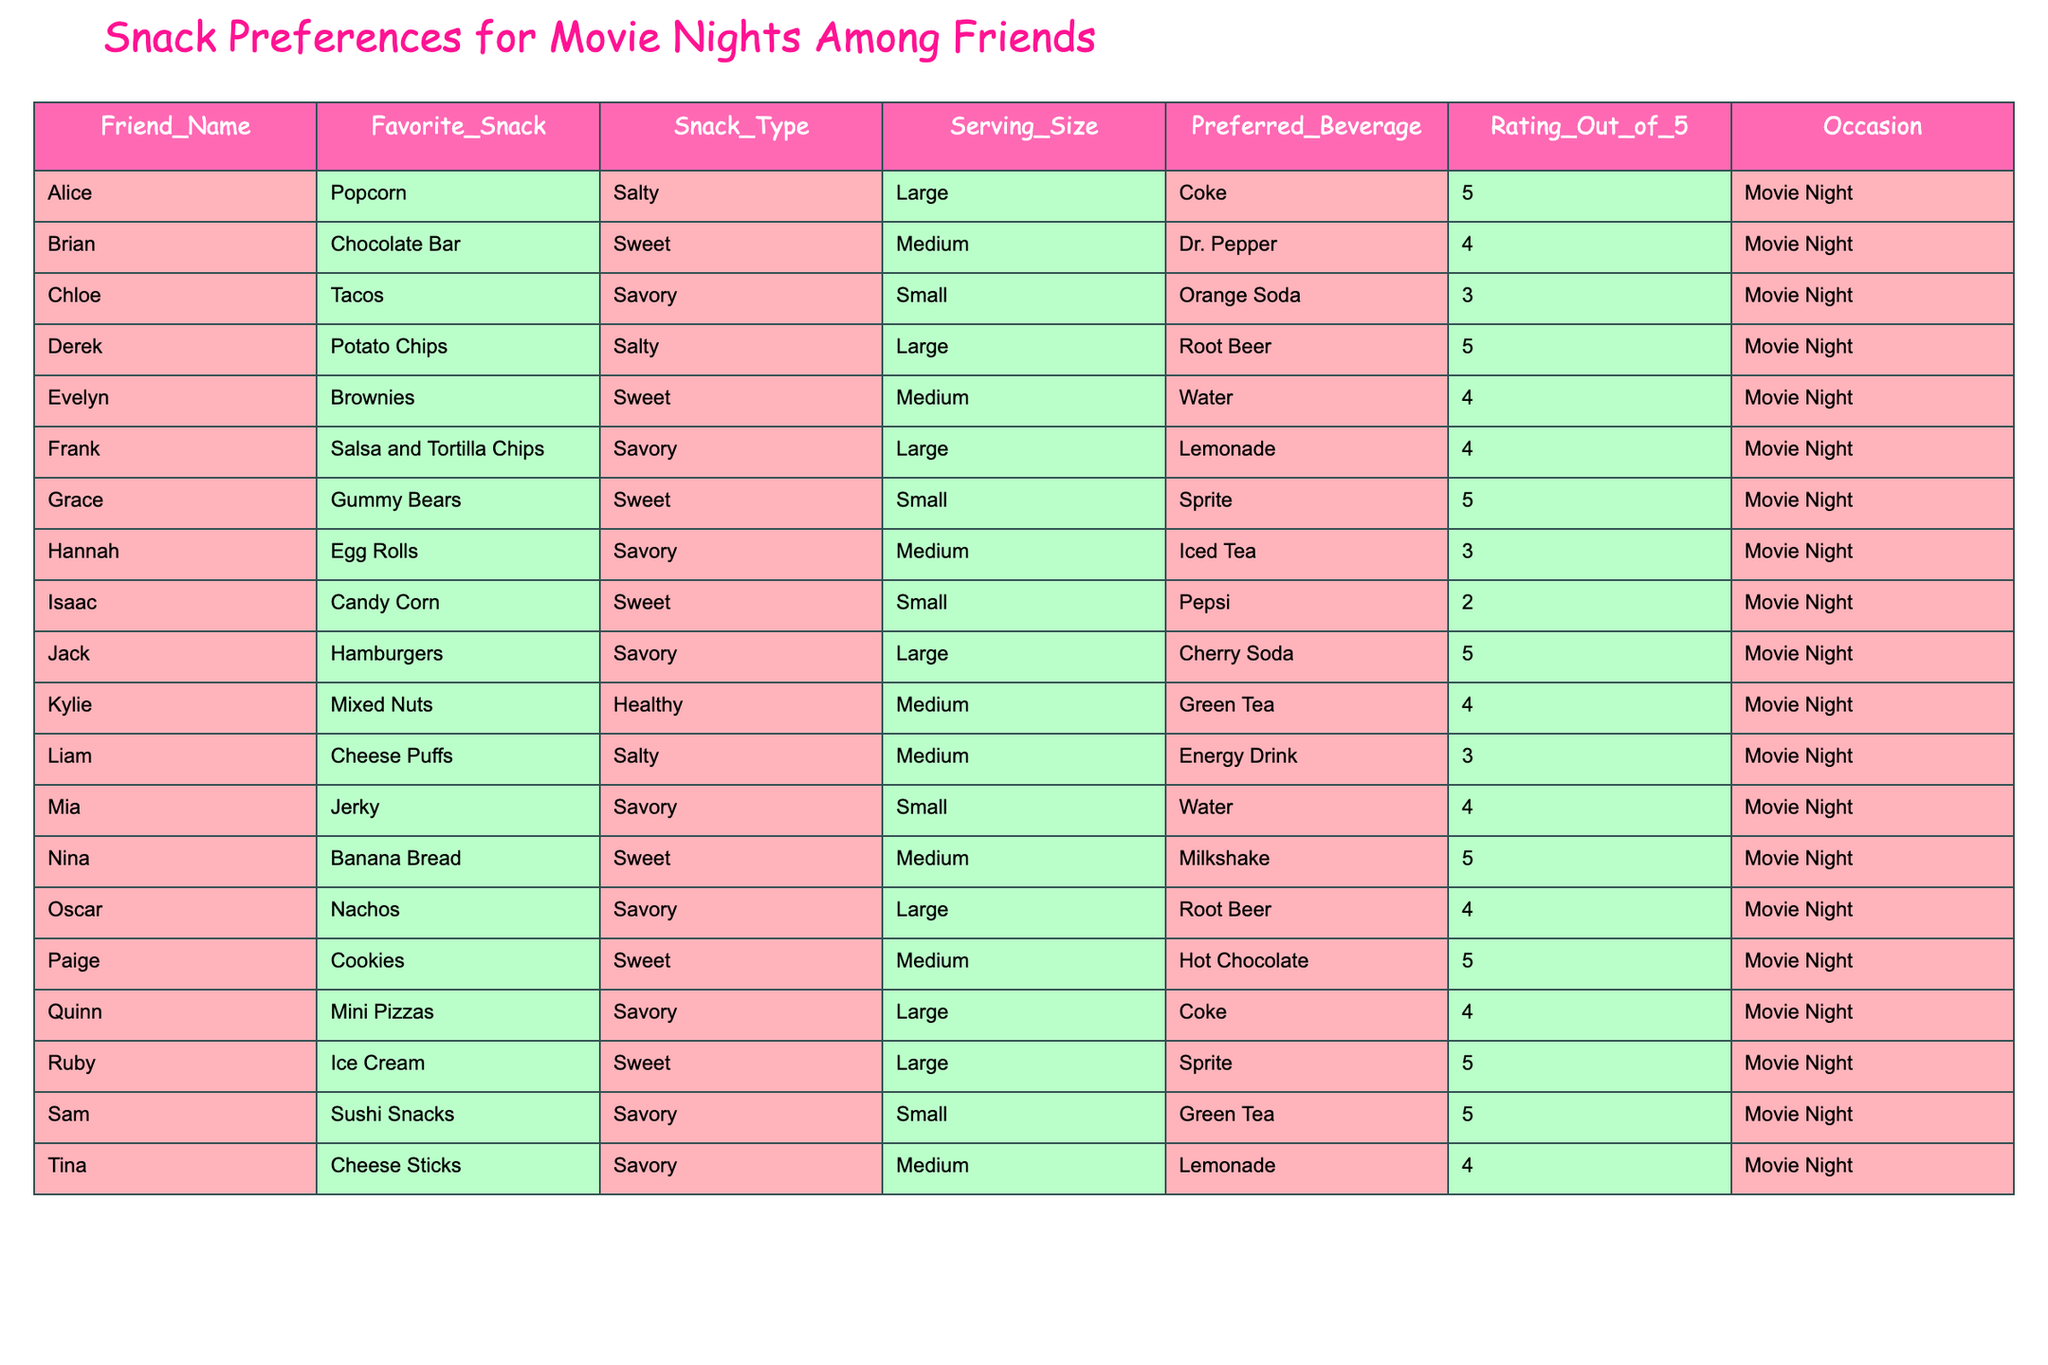What is Derek's favorite snack? The table lists Derek's favorite snack in the row identified by his name, which is "Potato Chips".
Answer: Potato Chips How many friends rated their favorite snack a 5 out of 5? Count the number of friends in the table whose rating is 5. These friends are Alice, Derek, Grace, Jack, Nina, Paige, Ruby, and Sam, totaling 8 friends.
Answer: 8 What is the favorite beverage of Chloe? By looking at Chloe's row in the table, her preferred beverage is displayed as "Orange Soda".
Answer: Orange Soda Which snack type has the highest average rating? First, group the snacks by type (Salty, Sweet, Savory, Healthy) and calculate the average rating for each type. Sweet has 4 snacks with an average of 4.25, Salty has 5 snacks with an average of 3.4, Savory has 6 snacks with an average of 4.0, and Healthy has 1 snack with a rating of 4. Therefore, Sweet has the highest average rating.
Answer: Sweet Is there any friend who prefers both a medium serving size and a sweet snack? Search the table to find any rows where the snack is classified as "Sweet" and has a "Medium" serving size. Here, both Brian and Evelyn have this preference.
Answer: Yes What is the preferred beverage of friends who rated their snacks a 2 or lower? Check the ratings column for any friends with a rating of 2 or lower. Here, only Isaac has a rating of 2, and his preferred beverage is "Pepsi."
Answer: Pepsi Which friend has a savory snack with the largest serving size? Inspect the savory snacks and their serving sizes. Jack has "Hamburgers" listed as a savory snack with "Large" serving size, confirming it as the largest for this category.
Answer: Jack How many snacks are rated above average (4 or higher)? First, we calculate the criteria for ratings above average: the ratings are divided into five categories. Counting the snacks rated 4 or higher gives us Alice, Brian, Derek, Evelyn, Frank, Grace, Jack, Kylie, Mia, Nina, Oscar, Paige, Quinn, Ruby, Sam, and Tina—totaling 15 snacks.
Answer: 15 Which savory snack has the lowest rating? Look at the savory snacks and their ratings. Among them, Chloe with "Tacos" has the lowest rating of 3.
Answer: Tacos Are there more sweet snacks or savory snacks in total? Count the number of entries for each snack type; there are 8 sweet snacks and 6 savory snacks. Since 8 is greater than 6, there are more sweet snacks.
Answer: Sweet snacks 